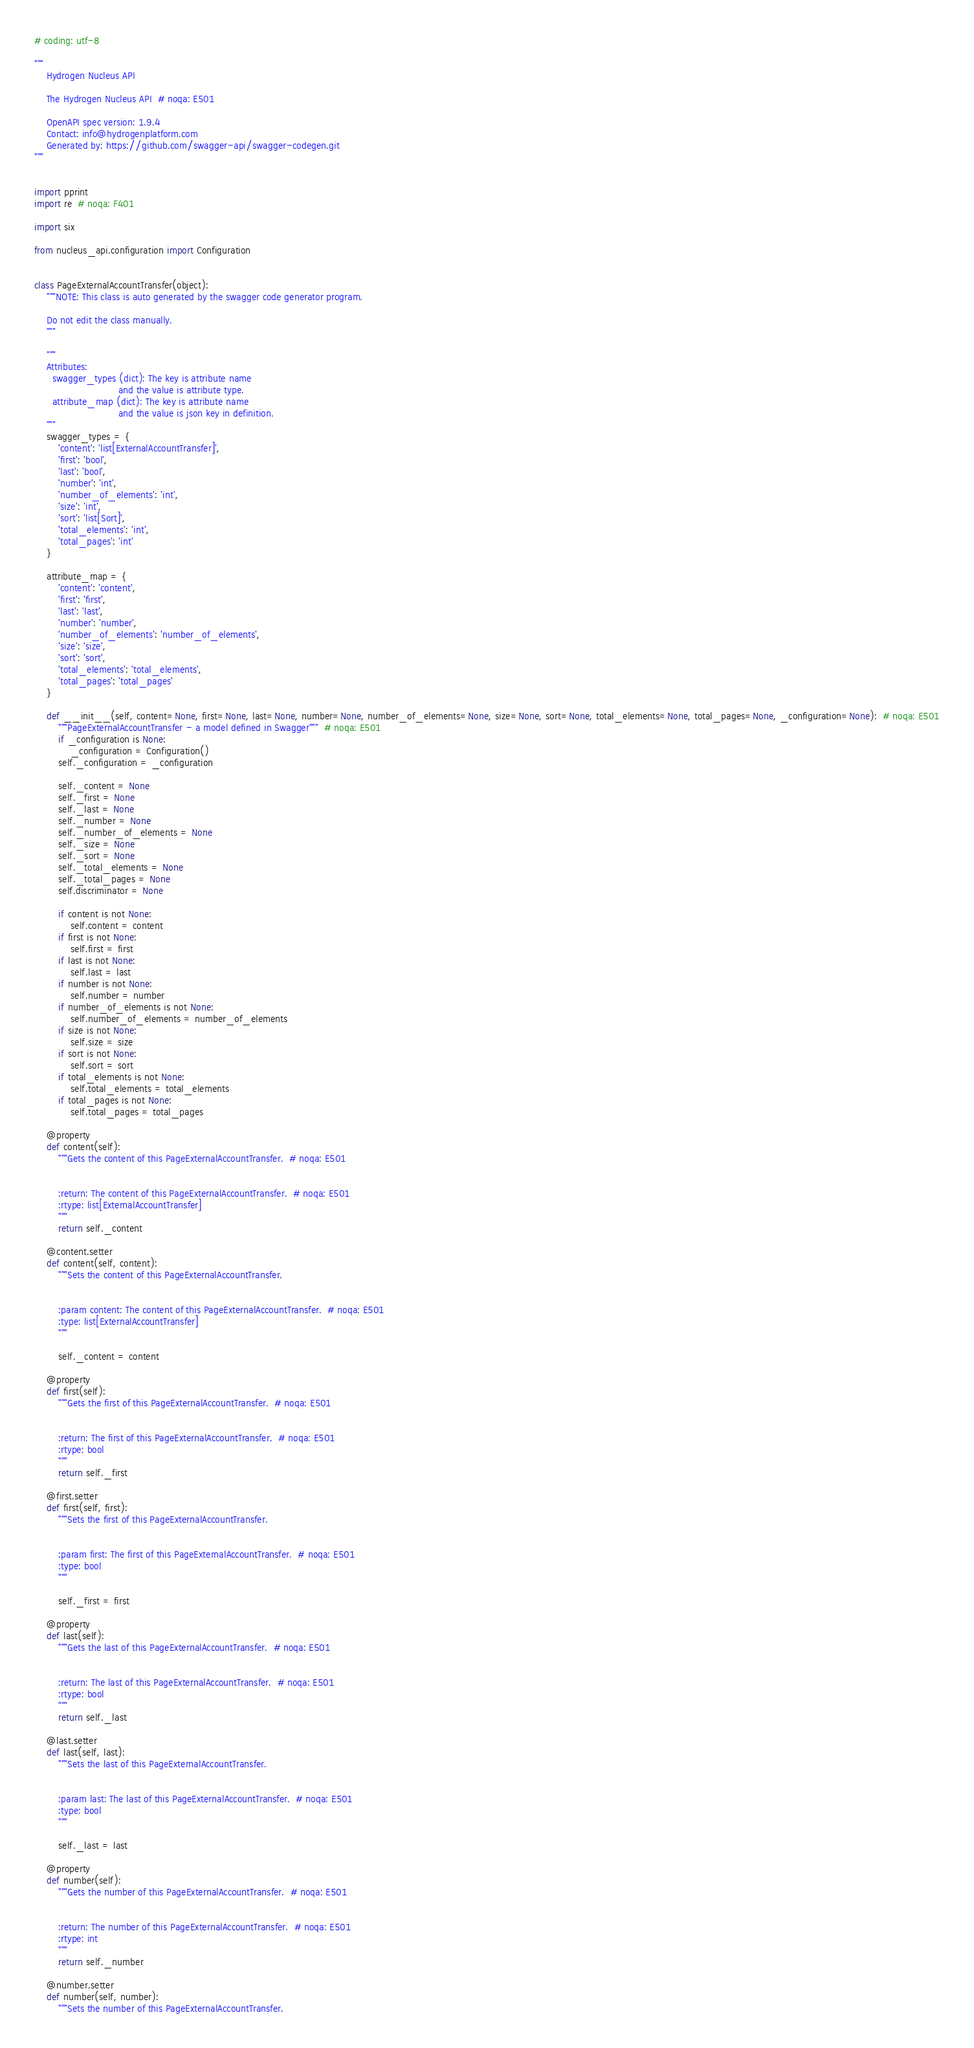Convert code to text. <code><loc_0><loc_0><loc_500><loc_500><_Python_># coding: utf-8

"""
    Hydrogen Nucleus API

    The Hydrogen Nucleus API  # noqa: E501

    OpenAPI spec version: 1.9.4
    Contact: info@hydrogenplatform.com
    Generated by: https://github.com/swagger-api/swagger-codegen.git
"""


import pprint
import re  # noqa: F401

import six

from nucleus_api.configuration import Configuration


class PageExternalAccountTransfer(object):
    """NOTE: This class is auto generated by the swagger code generator program.

    Do not edit the class manually.
    """

    """
    Attributes:
      swagger_types (dict): The key is attribute name
                            and the value is attribute type.
      attribute_map (dict): The key is attribute name
                            and the value is json key in definition.
    """
    swagger_types = {
        'content': 'list[ExternalAccountTransfer]',
        'first': 'bool',
        'last': 'bool',
        'number': 'int',
        'number_of_elements': 'int',
        'size': 'int',
        'sort': 'list[Sort]',
        'total_elements': 'int',
        'total_pages': 'int'
    }

    attribute_map = {
        'content': 'content',
        'first': 'first',
        'last': 'last',
        'number': 'number',
        'number_of_elements': 'number_of_elements',
        'size': 'size',
        'sort': 'sort',
        'total_elements': 'total_elements',
        'total_pages': 'total_pages'
    }

    def __init__(self, content=None, first=None, last=None, number=None, number_of_elements=None, size=None, sort=None, total_elements=None, total_pages=None, _configuration=None):  # noqa: E501
        """PageExternalAccountTransfer - a model defined in Swagger"""  # noqa: E501
        if _configuration is None:
            _configuration = Configuration()
        self._configuration = _configuration

        self._content = None
        self._first = None
        self._last = None
        self._number = None
        self._number_of_elements = None
        self._size = None
        self._sort = None
        self._total_elements = None
        self._total_pages = None
        self.discriminator = None

        if content is not None:
            self.content = content
        if first is not None:
            self.first = first
        if last is not None:
            self.last = last
        if number is not None:
            self.number = number
        if number_of_elements is not None:
            self.number_of_elements = number_of_elements
        if size is not None:
            self.size = size
        if sort is not None:
            self.sort = sort
        if total_elements is not None:
            self.total_elements = total_elements
        if total_pages is not None:
            self.total_pages = total_pages

    @property
    def content(self):
        """Gets the content of this PageExternalAccountTransfer.  # noqa: E501


        :return: The content of this PageExternalAccountTransfer.  # noqa: E501
        :rtype: list[ExternalAccountTransfer]
        """
        return self._content

    @content.setter
    def content(self, content):
        """Sets the content of this PageExternalAccountTransfer.


        :param content: The content of this PageExternalAccountTransfer.  # noqa: E501
        :type: list[ExternalAccountTransfer]
        """

        self._content = content

    @property
    def first(self):
        """Gets the first of this PageExternalAccountTransfer.  # noqa: E501


        :return: The first of this PageExternalAccountTransfer.  # noqa: E501
        :rtype: bool
        """
        return self._first

    @first.setter
    def first(self, first):
        """Sets the first of this PageExternalAccountTransfer.


        :param first: The first of this PageExternalAccountTransfer.  # noqa: E501
        :type: bool
        """

        self._first = first

    @property
    def last(self):
        """Gets the last of this PageExternalAccountTransfer.  # noqa: E501


        :return: The last of this PageExternalAccountTransfer.  # noqa: E501
        :rtype: bool
        """
        return self._last

    @last.setter
    def last(self, last):
        """Sets the last of this PageExternalAccountTransfer.


        :param last: The last of this PageExternalAccountTransfer.  # noqa: E501
        :type: bool
        """

        self._last = last

    @property
    def number(self):
        """Gets the number of this PageExternalAccountTransfer.  # noqa: E501


        :return: The number of this PageExternalAccountTransfer.  # noqa: E501
        :rtype: int
        """
        return self._number

    @number.setter
    def number(self, number):
        """Sets the number of this PageExternalAccountTransfer.

</code> 